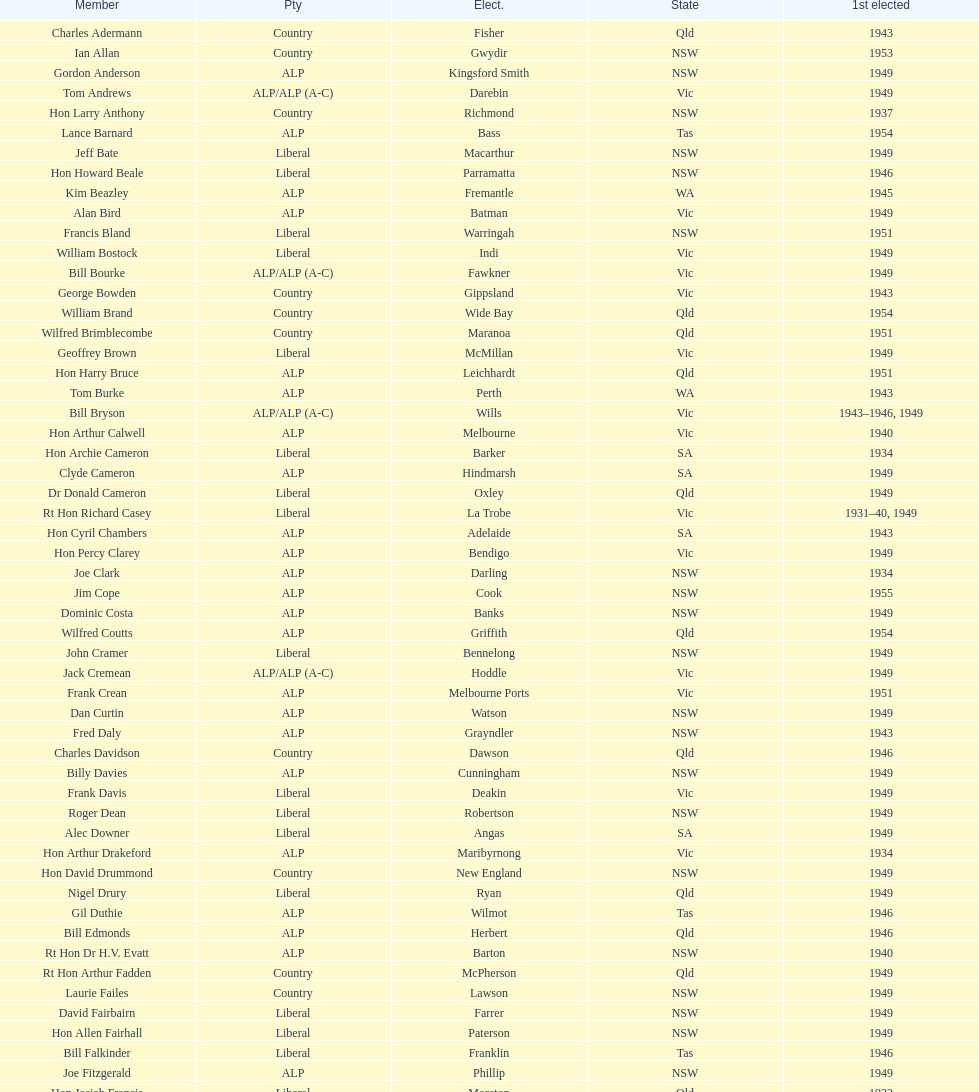Did tom burke run as country or alp party? ALP. 